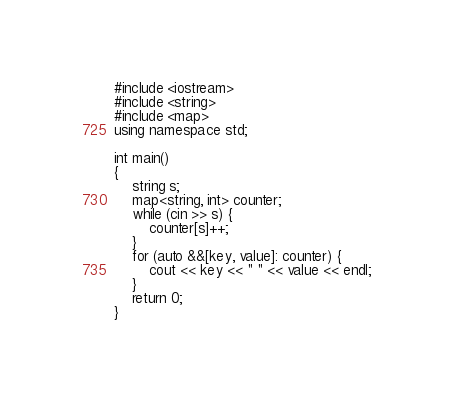Convert code to text. <code><loc_0><loc_0><loc_500><loc_500><_C++_>#include <iostream>
#include <string>
#include <map>
using namespace std;

int main()
{
    string s;
    map<string, int> counter;
    while (cin >> s) {
        counter[s]++;
    }
    for (auto &&[key, value]: counter) {
        cout << key << " " << value << endl;
    }
    return 0;
}</code> 